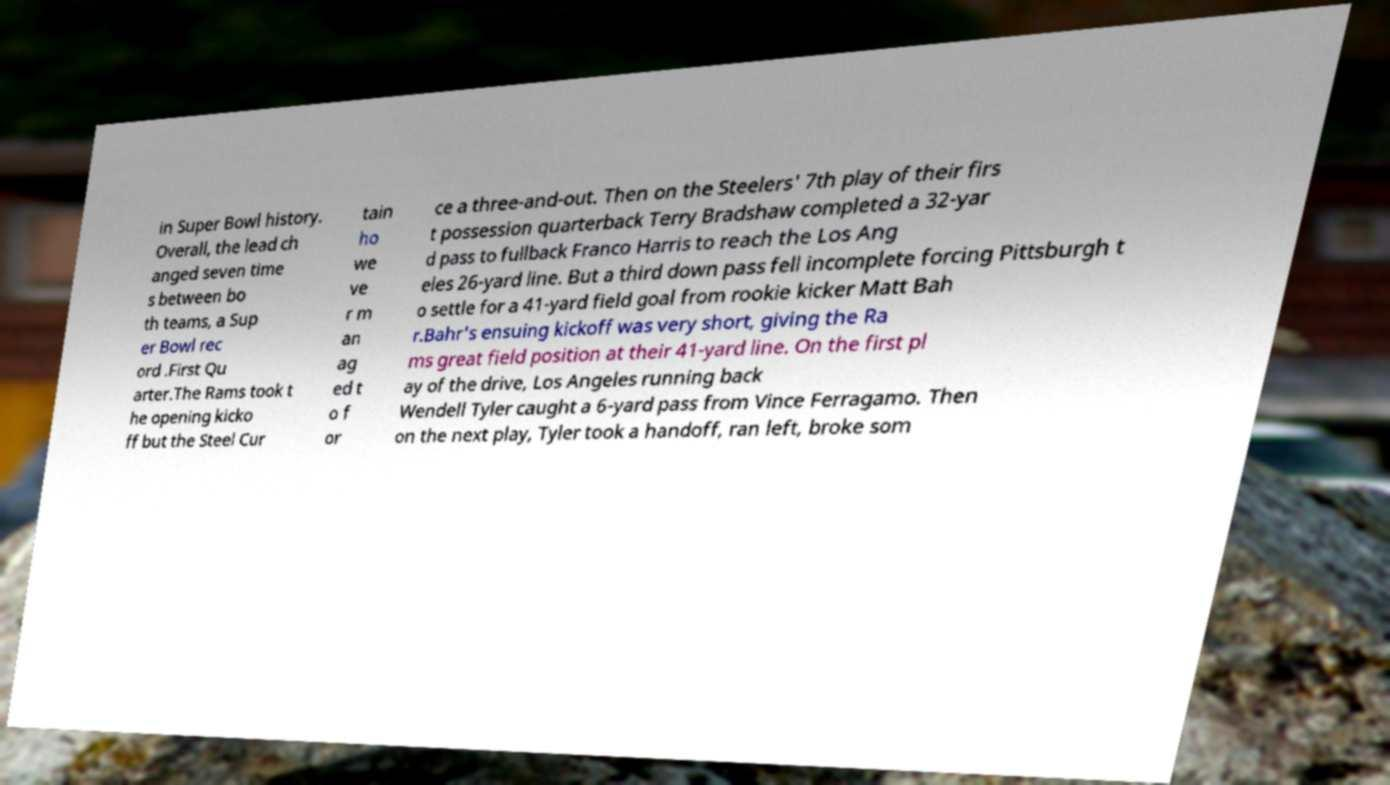There's text embedded in this image that I need extracted. Can you transcribe it verbatim? in Super Bowl history. Overall, the lead ch anged seven time s between bo th teams, a Sup er Bowl rec ord .First Qu arter.The Rams took t he opening kicko ff but the Steel Cur tain ho we ve r m an ag ed t o f or ce a three-and-out. Then on the Steelers' 7th play of their firs t possession quarterback Terry Bradshaw completed a 32-yar d pass to fullback Franco Harris to reach the Los Ang eles 26-yard line. But a third down pass fell incomplete forcing Pittsburgh t o settle for a 41-yard field goal from rookie kicker Matt Bah r.Bahr's ensuing kickoff was very short, giving the Ra ms great field position at their 41-yard line. On the first pl ay of the drive, Los Angeles running back Wendell Tyler caught a 6-yard pass from Vince Ferragamo. Then on the next play, Tyler took a handoff, ran left, broke som 